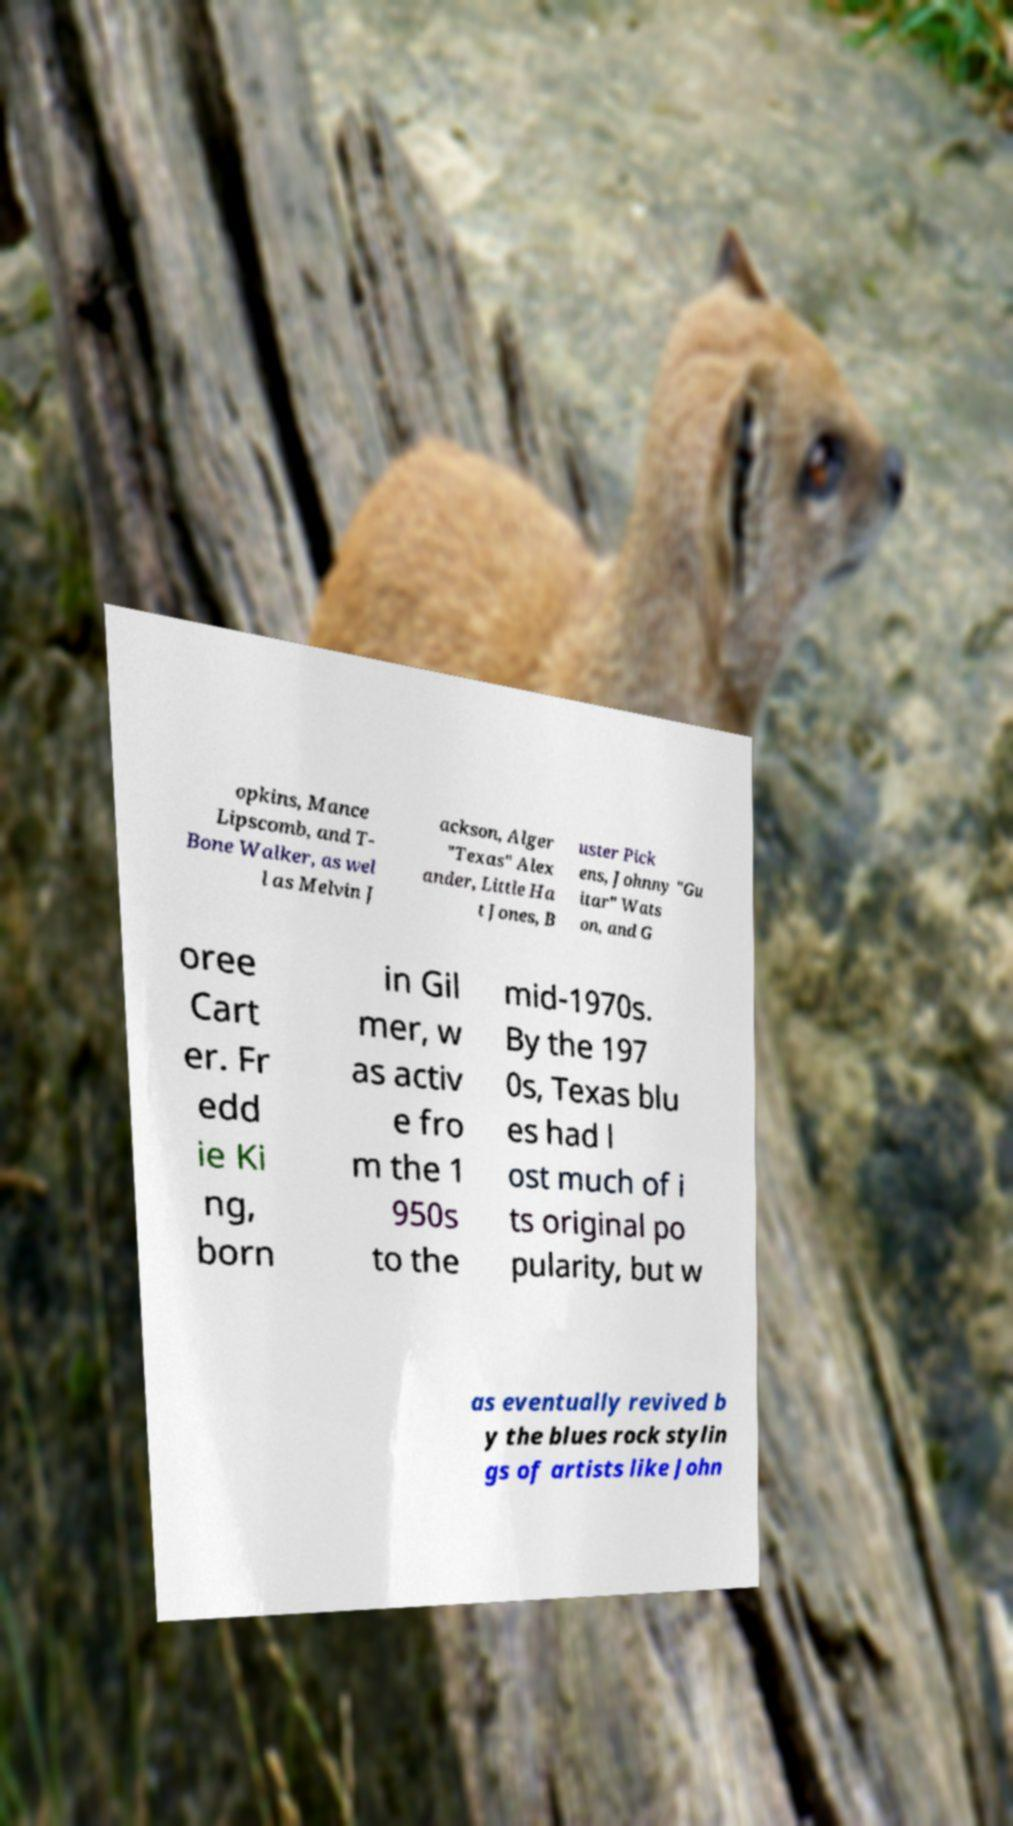There's text embedded in this image that I need extracted. Can you transcribe it verbatim? opkins, Mance Lipscomb, and T- Bone Walker, as wel l as Melvin J ackson, Alger "Texas" Alex ander, Little Ha t Jones, B uster Pick ens, Johnny "Gu itar" Wats on, and G oree Cart er. Fr edd ie Ki ng, born in Gil mer, w as activ e fro m the 1 950s to the mid-1970s. By the 197 0s, Texas blu es had l ost much of i ts original po pularity, but w as eventually revived b y the blues rock stylin gs of artists like John 